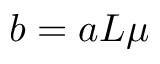<formula> <loc_0><loc_0><loc_500><loc_500>b = a L \mu</formula> 